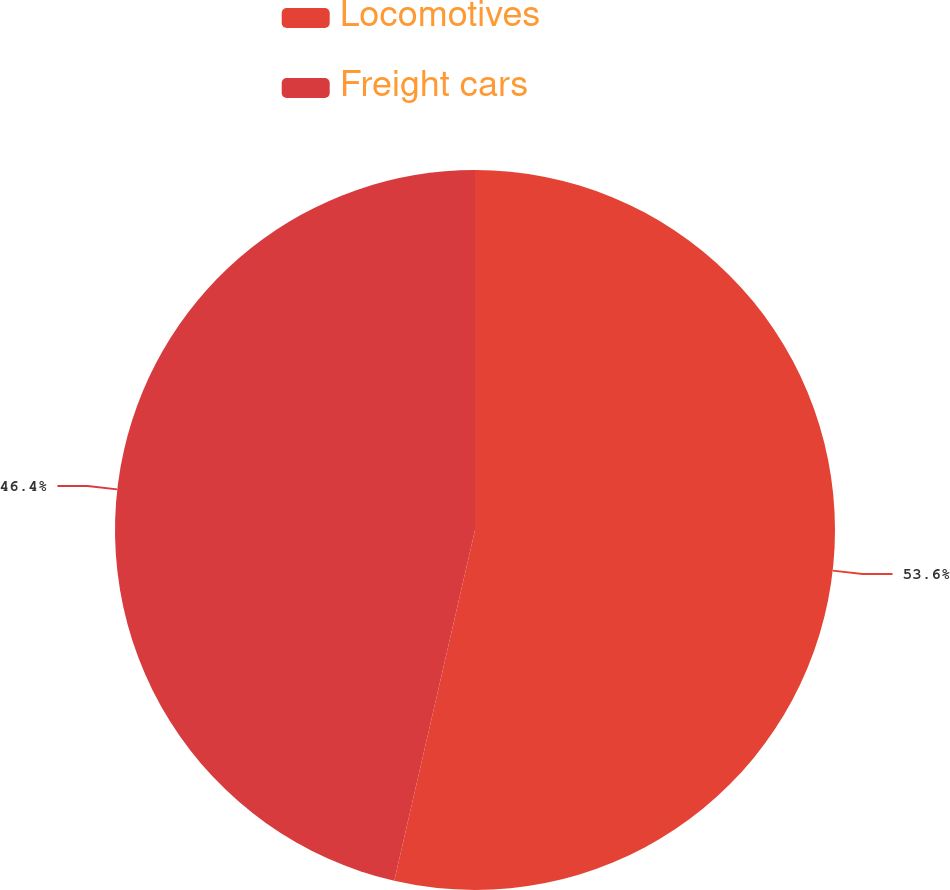Convert chart. <chart><loc_0><loc_0><loc_500><loc_500><pie_chart><fcel>Locomotives<fcel>Freight cars<nl><fcel>53.6%<fcel>46.4%<nl></chart> 